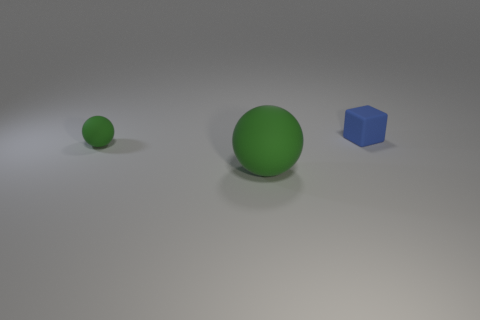Add 2 large green spheres. How many objects exist? 5 Subtract 1 cubes. How many cubes are left? 0 Subtract all balls. How many objects are left? 1 Subtract all cyan balls. Subtract all blue cylinders. How many balls are left? 2 Subtract all big brown rubber cylinders. Subtract all tiny objects. How many objects are left? 1 Add 1 small spheres. How many small spheres are left? 2 Add 3 tiny green spheres. How many tiny green spheres exist? 4 Subtract 0 red spheres. How many objects are left? 3 